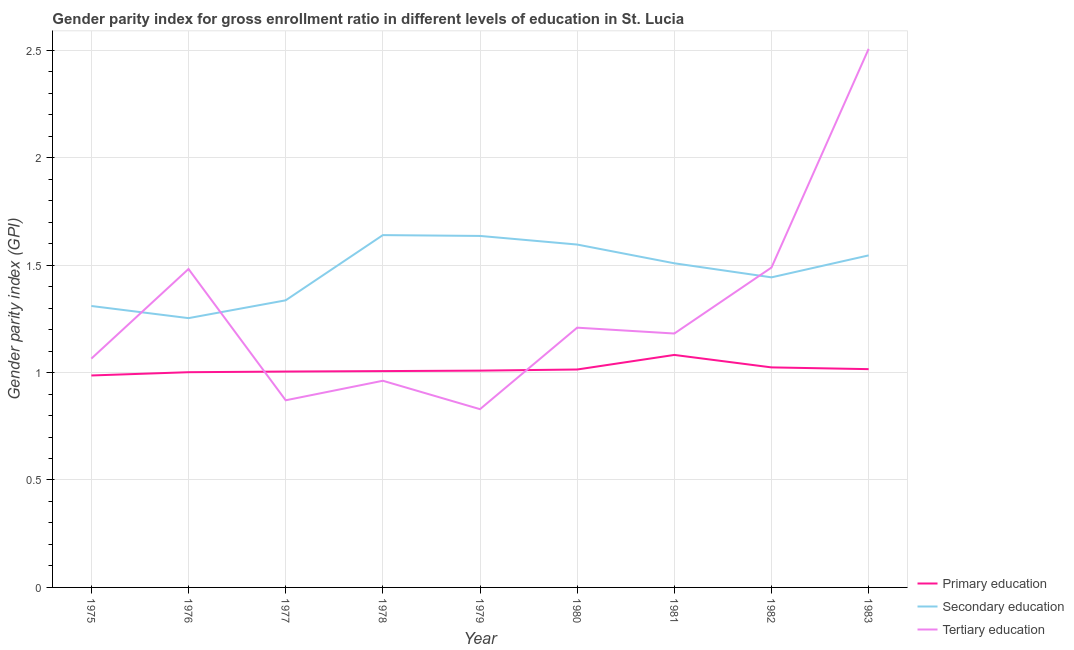How many different coloured lines are there?
Give a very brief answer. 3. Does the line corresponding to gender parity index in tertiary education intersect with the line corresponding to gender parity index in secondary education?
Ensure brevity in your answer.  Yes. What is the gender parity index in primary education in 1979?
Offer a very short reply. 1.01. Across all years, what is the maximum gender parity index in secondary education?
Your answer should be very brief. 1.64. Across all years, what is the minimum gender parity index in tertiary education?
Ensure brevity in your answer.  0.83. In which year was the gender parity index in secondary education maximum?
Provide a succinct answer. 1978. In which year was the gender parity index in tertiary education minimum?
Your response must be concise. 1979. What is the total gender parity index in primary education in the graph?
Your answer should be very brief. 9.14. What is the difference between the gender parity index in primary education in 1975 and that in 1983?
Your response must be concise. -0.03. What is the difference between the gender parity index in primary education in 1979 and the gender parity index in secondary education in 1978?
Your answer should be very brief. -0.63. What is the average gender parity index in tertiary education per year?
Provide a short and direct response. 1.29. In the year 1979, what is the difference between the gender parity index in tertiary education and gender parity index in primary education?
Your answer should be compact. -0.18. What is the ratio of the gender parity index in tertiary education in 1981 to that in 1983?
Your response must be concise. 0.47. Is the gender parity index in tertiary education in 1976 less than that in 1979?
Provide a short and direct response. No. What is the difference between the highest and the second highest gender parity index in tertiary education?
Provide a succinct answer. 1.02. What is the difference between the highest and the lowest gender parity index in primary education?
Your answer should be compact. 0.1. Is the sum of the gender parity index in tertiary education in 1976 and 1982 greater than the maximum gender parity index in secondary education across all years?
Offer a very short reply. Yes. Is it the case that in every year, the sum of the gender parity index in primary education and gender parity index in secondary education is greater than the gender parity index in tertiary education?
Your response must be concise. Yes. Does the gender parity index in primary education monotonically increase over the years?
Your answer should be compact. No. Is the gender parity index in tertiary education strictly less than the gender parity index in secondary education over the years?
Your response must be concise. No. How many years are there in the graph?
Give a very brief answer. 9. Are the values on the major ticks of Y-axis written in scientific E-notation?
Make the answer very short. No. How many legend labels are there?
Give a very brief answer. 3. What is the title of the graph?
Offer a terse response. Gender parity index for gross enrollment ratio in different levels of education in St. Lucia. Does "Maunufacturing" appear as one of the legend labels in the graph?
Make the answer very short. No. What is the label or title of the X-axis?
Provide a succinct answer. Year. What is the label or title of the Y-axis?
Provide a succinct answer. Gender parity index (GPI). What is the Gender parity index (GPI) of Primary education in 1975?
Offer a terse response. 0.99. What is the Gender parity index (GPI) in Secondary education in 1975?
Provide a short and direct response. 1.31. What is the Gender parity index (GPI) in Tertiary education in 1975?
Provide a short and direct response. 1.06. What is the Gender parity index (GPI) of Primary education in 1976?
Your answer should be compact. 1. What is the Gender parity index (GPI) in Secondary education in 1976?
Keep it short and to the point. 1.25. What is the Gender parity index (GPI) in Tertiary education in 1976?
Provide a short and direct response. 1.48. What is the Gender parity index (GPI) of Primary education in 1977?
Offer a terse response. 1. What is the Gender parity index (GPI) in Secondary education in 1977?
Your answer should be very brief. 1.34. What is the Gender parity index (GPI) in Tertiary education in 1977?
Keep it short and to the point. 0.87. What is the Gender parity index (GPI) in Primary education in 1978?
Keep it short and to the point. 1.01. What is the Gender parity index (GPI) of Secondary education in 1978?
Ensure brevity in your answer.  1.64. What is the Gender parity index (GPI) in Tertiary education in 1978?
Keep it short and to the point. 0.96. What is the Gender parity index (GPI) in Primary education in 1979?
Offer a terse response. 1.01. What is the Gender parity index (GPI) of Secondary education in 1979?
Make the answer very short. 1.64. What is the Gender parity index (GPI) in Tertiary education in 1979?
Offer a very short reply. 0.83. What is the Gender parity index (GPI) in Primary education in 1980?
Make the answer very short. 1.01. What is the Gender parity index (GPI) in Secondary education in 1980?
Keep it short and to the point. 1.6. What is the Gender parity index (GPI) in Tertiary education in 1980?
Offer a very short reply. 1.21. What is the Gender parity index (GPI) in Primary education in 1981?
Provide a succinct answer. 1.08. What is the Gender parity index (GPI) of Secondary education in 1981?
Give a very brief answer. 1.51. What is the Gender parity index (GPI) of Tertiary education in 1981?
Offer a terse response. 1.18. What is the Gender parity index (GPI) in Primary education in 1982?
Offer a very short reply. 1.02. What is the Gender parity index (GPI) of Secondary education in 1982?
Your response must be concise. 1.44. What is the Gender parity index (GPI) of Tertiary education in 1982?
Provide a short and direct response. 1.49. What is the Gender parity index (GPI) in Primary education in 1983?
Keep it short and to the point. 1.02. What is the Gender parity index (GPI) in Secondary education in 1983?
Provide a succinct answer. 1.55. What is the Gender parity index (GPI) of Tertiary education in 1983?
Make the answer very short. 2.51. Across all years, what is the maximum Gender parity index (GPI) in Primary education?
Give a very brief answer. 1.08. Across all years, what is the maximum Gender parity index (GPI) of Secondary education?
Give a very brief answer. 1.64. Across all years, what is the maximum Gender parity index (GPI) in Tertiary education?
Offer a very short reply. 2.51. Across all years, what is the minimum Gender parity index (GPI) of Primary education?
Your answer should be very brief. 0.99. Across all years, what is the minimum Gender parity index (GPI) of Secondary education?
Provide a short and direct response. 1.25. Across all years, what is the minimum Gender parity index (GPI) in Tertiary education?
Offer a very short reply. 0.83. What is the total Gender parity index (GPI) in Primary education in the graph?
Your answer should be compact. 9.14. What is the total Gender parity index (GPI) of Secondary education in the graph?
Make the answer very short. 13.27. What is the total Gender parity index (GPI) of Tertiary education in the graph?
Your response must be concise. 11.59. What is the difference between the Gender parity index (GPI) in Primary education in 1975 and that in 1976?
Your answer should be compact. -0.02. What is the difference between the Gender parity index (GPI) in Secondary education in 1975 and that in 1976?
Offer a terse response. 0.06. What is the difference between the Gender parity index (GPI) of Tertiary education in 1975 and that in 1976?
Provide a succinct answer. -0.42. What is the difference between the Gender parity index (GPI) of Primary education in 1975 and that in 1977?
Provide a succinct answer. -0.02. What is the difference between the Gender parity index (GPI) in Secondary education in 1975 and that in 1977?
Offer a terse response. -0.03. What is the difference between the Gender parity index (GPI) of Tertiary education in 1975 and that in 1977?
Your answer should be compact. 0.19. What is the difference between the Gender parity index (GPI) in Primary education in 1975 and that in 1978?
Offer a terse response. -0.02. What is the difference between the Gender parity index (GPI) in Secondary education in 1975 and that in 1978?
Your answer should be very brief. -0.33. What is the difference between the Gender parity index (GPI) in Tertiary education in 1975 and that in 1978?
Ensure brevity in your answer.  0.1. What is the difference between the Gender parity index (GPI) of Primary education in 1975 and that in 1979?
Ensure brevity in your answer.  -0.02. What is the difference between the Gender parity index (GPI) in Secondary education in 1975 and that in 1979?
Your answer should be very brief. -0.33. What is the difference between the Gender parity index (GPI) in Tertiary education in 1975 and that in 1979?
Provide a short and direct response. 0.24. What is the difference between the Gender parity index (GPI) of Primary education in 1975 and that in 1980?
Provide a short and direct response. -0.03. What is the difference between the Gender parity index (GPI) in Secondary education in 1975 and that in 1980?
Your answer should be compact. -0.29. What is the difference between the Gender parity index (GPI) in Tertiary education in 1975 and that in 1980?
Give a very brief answer. -0.14. What is the difference between the Gender parity index (GPI) of Primary education in 1975 and that in 1981?
Offer a very short reply. -0.1. What is the difference between the Gender parity index (GPI) in Secondary education in 1975 and that in 1981?
Give a very brief answer. -0.2. What is the difference between the Gender parity index (GPI) in Tertiary education in 1975 and that in 1981?
Offer a terse response. -0.12. What is the difference between the Gender parity index (GPI) of Primary education in 1975 and that in 1982?
Your response must be concise. -0.04. What is the difference between the Gender parity index (GPI) in Secondary education in 1975 and that in 1982?
Provide a succinct answer. -0.13. What is the difference between the Gender parity index (GPI) in Tertiary education in 1975 and that in 1982?
Your answer should be very brief. -0.42. What is the difference between the Gender parity index (GPI) in Primary education in 1975 and that in 1983?
Provide a succinct answer. -0.03. What is the difference between the Gender parity index (GPI) of Secondary education in 1975 and that in 1983?
Make the answer very short. -0.24. What is the difference between the Gender parity index (GPI) in Tertiary education in 1975 and that in 1983?
Ensure brevity in your answer.  -1.44. What is the difference between the Gender parity index (GPI) of Primary education in 1976 and that in 1977?
Keep it short and to the point. -0. What is the difference between the Gender parity index (GPI) of Secondary education in 1976 and that in 1977?
Your answer should be compact. -0.08. What is the difference between the Gender parity index (GPI) of Tertiary education in 1976 and that in 1977?
Make the answer very short. 0.61. What is the difference between the Gender parity index (GPI) of Primary education in 1976 and that in 1978?
Keep it short and to the point. -0.01. What is the difference between the Gender parity index (GPI) in Secondary education in 1976 and that in 1978?
Provide a short and direct response. -0.39. What is the difference between the Gender parity index (GPI) of Tertiary education in 1976 and that in 1978?
Offer a very short reply. 0.52. What is the difference between the Gender parity index (GPI) of Primary education in 1976 and that in 1979?
Make the answer very short. -0.01. What is the difference between the Gender parity index (GPI) in Secondary education in 1976 and that in 1979?
Provide a succinct answer. -0.38. What is the difference between the Gender parity index (GPI) in Tertiary education in 1976 and that in 1979?
Make the answer very short. 0.65. What is the difference between the Gender parity index (GPI) of Primary education in 1976 and that in 1980?
Keep it short and to the point. -0.01. What is the difference between the Gender parity index (GPI) in Secondary education in 1976 and that in 1980?
Make the answer very short. -0.34. What is the difference between the Gender parity index (GPI) of Tertiary education in 1976 and that in 1980?
Provide a succinct answer. 0.27. What is the difference between the Gender parity index (GPI) of Primary education in 1976 and that in 1981?
Ensure brevity in your answer.  -0.08. What is the difference between the Gender parity index (GPI) of Secondary education in 1976 and that in 1981?
Keep it short and to the point. -0.26. What is the difference between the Gender parity index (GPI) in Tertiary education in 1976 and that in 1981?
Provide a short and direct response. 0.3. What is the difference between the Gender parity index (GPI) of Primary education in 1976 and that in 1982?
Ensure brevity in your answer.  -0.02. What is the difference between the Gender parity index (GPI) in Secondary education in 1976 and that in 1982?
Make the answer very short. -0.19. What is the difference between the Gender parity index (GPI) of Tertiary education in 1976 and that in 1982?
Your answer should be compact. -0.01. What is the difference between the Gender parity index (GPI) in Primary education in 1976 and that in 1983?
Offer a terse response. -0.01. What is the difference between the Gender parity index (GPI) in Secondary education in 1976 and that in 1983?
Your answer should be compact. -0.29. What is the difference between the Gender parity index (GPI) in Tertiary education in 1976 and that in 1983?
Ensure brevity in your answer.  -1.02. What is the difference between the Gender parity index (GPI) in Primary education in 1977 and that in 1978?
Ensure brevity in your answer.  -0. What is the difference between the Gender parity index (GPI) of Secondary education in 1977 and that in 1978?
Your answer should be very brief. -0.3. What is the difference between the Gender parity index (GPI) of Tertiary education in 1977 and that in 1978?
Your answer should be compact. -0.09. What is the difference between the Gender parity index (GPI) in Primary education in 1977 and that in 1979?
Your response must be concise. -0. What is the difference between the Gender parity index (GPI) in Secondary education in 1977 and that in 1979?
Ensure brevity in your answer.  -0.3. What is the difference between the Gender parity index (GPI) in Tertiary education in 1977 and that in 1979?
Make the answer very short. 0.04. What is the difference between the Gender parity index (GPI) in Primary education in 1977 and that in 1980?
Provide a succinct answer. -0.01. What is the difference between the Gender parity index (GPI) in Secondary education in 1977 and that in 1980?
Give a very brief answer. -0.26. What is the difference between the Gender parity index (GPI) in Tertiary education in 1977 and that in 1980?
Your response must be concise. -0.34. What is the difference between the Gender parity index (GPI) in Primary education in 1977 and that in 1981?
Provide a succinct answer. -0.08. What is the difference between the Gender parity index (GPI) of Secondary education in 1977 and that in 1981?
Your response must be concise. -0.17. What is the difference between the Gender parity index (GPI) in Tertiary education in 1977 and that in 1981?
Your answer should be very brief. -0.31. What is the difference between the Gender parity index (GPI) of Primary education in 1977 and that in 1982?
Your answer should be compact. -0.02. What is the difference between the Gender parity index (GPI) of Secondary education in 1977 and that in 1982?
Give a very brief answer. -0.11. What is the difference between the Gender parity index (GPI) in Tertiary education in 1977 and that in 1982?
Keep it short and to the point. -0.62. What is the difference between the Gender parity index (GPI) in Primary education in 1977 and that in 1983?
Your answer should be compact. -0.01. What is the difference between the Gender parity index (GPI) of Secondary education in 1977 and that in 1983?
Offer a very short reply. -0.21. What is the difference between the Gender parity index (GPI) of Tertiary education in 1977 and that in 1983?
Your response must be concise. -1.64. What is the difference between the Gender parity index (GPI) in Primary education in 1978 and that in 1979?
Your response must be concise. -0. What is the difference between the Gender parity index (GPI) in Secondary education in 1978 and that in 1979?
Offer a very short reply. 0. What is the difference between the Gender parity index (GPI) in Tertiary education in 1978 and that in 1979?
Keep it short and to the point. 0.13. What is the difference between the Gender parity index (GPI) in Primary education in 1978 and that in 1980?
Your answer should be very brief. -0.01. What is the difference between the Gender parity index (GPI) in Secondary education in 1978 and that in 1980?
Provide a succinct answer. 0.04. What is the difference between the Gender parity index (GPI) in Tertiary education in 1978 and that in 1980?
Provide a succinct answer. -0.25. What is the difference between the Gender parity index (GPI) of Primary education in 1978 and that in 1981?
Your answer should be very brief. -0.08. What is the difference between the Gender parity index (GPI) in Secondary education in 1978 and that in 1981?
Give a very brief answer. 0.13. What is the difference between the Gender parity index (GPI) of Tertiary education in 1978 and that in 1981?
Offer a terse response. -0.22. What is the difference between the Gender parity index (GPI) in Primary education in 1978 and that in 1982?
Provide a short and direct response. -0.02. What is the difference between the Gender parity index (GPI) of Secondary education in 1978 and that in 1982?
Provide a succinct answer. 0.2. What is the difference between the Gender parity index (GPI) in Tertiary education in 1978 and that in 1982?
Give a very brief answer. -0.53. What is the difference between the Gender parity index (GPI) in Primary education in 1978 and that in 1983?
Make the answer very short. -0.01. What is the difference between the Gender parity index (GPI) of Secondary education in 1978 and that in 1983?
Keep it short and to the point. 0.09. What is the difference between the Gender parity index (GPI) in Tertiary education in 1978 and that in 1983?
Provide a short and direct response. -1.54. What is the difference between the Gender parity index (GPI) in Primary education in 1979 and that in 1980?
Offer a terse response. -0.01. What is the difference between the Gender parity index (GPI) of Secondary education in 1979 and that in 1980?
Offer a very short reply. 0.04. What is the difference between the Gender parity index (GPI) in Tertiary education in 1979 and that in 1980?
Offer a very short reply. -0.38. What is the difference between the Gender parity index (GPI) in Primary education in 1979 and that in 1981?
Ensure brevity in your answer.  -0.07. What is the difference between the Gender parity index (GPI) of Secondary education in 1979 and that in 1981?
Provide a short and direct response. 0.13. What is the difference between the Gender parity index (GPI) in Tertiary education in 1979 and that in 1981?
Your answer should be very brief. -0.35. What is the difference between the Gender parity index (GPI) of Primary education in 1979 and that in 1982?
Offer a very short reply. -0.01. What is the difference between the Gender parity index (GPI) in Secondary education in 1979 and that in 1982?
Give a very brief answer. 0.19. What is the difference between the Gender parity index (GPI) of Tertiary education in 1979 and that in 1982?
Keep it short and to the point. -0.66. What is the difference between the Gender parity index (GPI) in Primary education in 1979 and that in 1983?
Keep it short and to the point. -0.01. What is the difference between the Gender parity index (GPI) of Secondary education in 1979 and that in 1983?
Provide a short and direct response. 0.09. What is the difference between the Gender parity index (GPI) in Tertiary education in 1979 and that in 1983?
Provide a succinct answer. -1.68. What is the difference between the Gender parity index (GPI) in Primary education in 1980 and that in 1981?
Your answer should be compact. -0.07. What is the difference between the Gender parity index (GPI) of Secondary education in 1980 and that in 1981?
Your response must be concise. 0.09. What is the difference between the Gender parity index (GPI) in Tertiary education in 1980 and that in 1981?
Give a very brief answer. 0.03. What is the difference between the Gender parity index (GPI) in Primary education in 1980 and that in 1982?
Offer a very short reply. -0.01. What is the difference between the Gender parity index (GPI) of Secondary education in 1980 and that in 1982?
Keep it short and to the point. 0.15. What is the difference between the Gender parity index (GPI) in Tertiary education in 1980 and that in 1982?
Make the answer very short. -0.28. What is the difference between the Gender parity index (GPI) in Primary education in 1980 and that in 1983?
Keep it short and to the point. -0. What is the difference between the Gender parity index (GPI) of Secondary education in 1980 and that in 1983?
Give a very brief answer. 0.05. What is the difference between the Gender parity index (GPI) in Tertiary education in 1980 and that in 1983?
Make the answer very short. -1.3. What is the difference between the Gender parity index (GPI) of Primary education in 1981 and that in 1982?
Your answer should be compact. 0.06. What is the difference between the Gender parity index (GPI) of Secondary education in 1981 and that in 1982?
Offer a terse response. 0.07. What is the difference between the Gender parity index (GPI) in Tertiary education in 1981 and that in 1982?
Provide a short and direct response. -0.31. What is the difference between the Gender parity index (GPI) in Primary education in 1981 and that in 1983?
Make the answer very short. 0.07. What is the difference between the Gender parity index (GPI) in Secondary education in 1981 and that in 1983?
Offer a very short reply. -0.04. What is the difference between the Gender parity index (GPI) of Tertiary education in 1981 and that in 1983?
Offer a terse response. -1.32. What is the difference between the Gender parity index (GPI) in Primary education in 1982 and that in 1983?
Offer a terse response. 0.01. What is the difference between the Gender parity index (GPI) of Secondary education in 1982 and that in 1983?
Make the answer very short. -0.1. What is the difference between the Gender parity index (GPI) in Tertiary education in 1982 and that in 1983?
Offer a terse response. -1.02. What is the difference between the Gender parity index (GPI) of Primary education in 1975 and the Gender parity index (GPI) of Secondary education in 1976?
Offer a terse response. -0.27. What is the difference between the Gender parity index (GPI) in Primary education in 1975 and the Gender parity index (GPI) in Tertiary education in 1976?
Offer a terse response. -0.5. What is the difference between the Gender parity index (GPI) of Secondary education in 1975 and the Gender parity index (GPI) of Tertiary education in 1976?
Provide a short and direct response. -0.17. What is the difference between the Gender parity index (GPI) in Primary education in 1975 and the Gender parity index (GPI) in Secondary education in 1977?
Provide a succinct answer. -0.35. What is the difference between the Gender parity index (GPI) in Primary education in 1975 and the Gender parity index (GPI) in Tertiary education in 1977?
Keep it short and to the point. 0.12. What is the difference between the Gender parity index (GPI) of Secondary education in 1975 and the Gender parity index (GPI) of Tertiary education in 1977?
Offer a very short reply. 0.44. What is the difference between the Gender parity index (GPI) of Primary education in 1975 and the Gender parity index (GPI) of Secondary education in 1978?
Your answer should be very brief. -0.65. What is the difference between the Gender parity index (GPI) in Primary education in 1975 and the Gender parity index (GPI) in Tertiary education in 1978?
Ensure brevity in your answer.  0.02. What is the difference between the Gender parity index (GPI) of Secondary education in 1975 and the Gender parity index (GPI) of Tertiary education in 1978?
Your response must be concise. 0.35. What is the difference between the Gender parity index (GPI) in Primary education in 1975 and the Gender parity index (GPI) in Secondary education in 1979?
Your answer should be very brief. -0.65. What is the difference between the Gender parity index (GPI) in Primary education in 1975 and the Gender parity index (GPI) in Tertiary education in 1979?
Provide a short and direct response. 0.16. What is the difference between the Gender parity index (GPI) of Secondary education in 1975 and the Gender parity index (GPI) of Tertiary education in 1979?
Provide a succinct answer. 0.48. What is the difference between the Gender parity index (GPI) of Primary education in 1975 and the Gender parity index (GPI) of Secondary education in 1980?
Offer a terse response. -0.61. What is the difference between the Gender parity index (GPI) in Primary education in 1975 and the Gender parity index (GPI) in Tertiary education in 1980?
Give a very brief answer. -0.22. What is the difference between the Gender parity index (GPI) in Secondary education in 1975 and the Gender parity index (GPI) in Tertiary education in 1980?
Provide a short and direct response. 0.1. What is the difference between the Gender parity index (GPI) of Primary education in 1975 and the Gender parity index (GPI) of Secondary education in 1981?
Your answer should be compact. -0.52. What is the difference between the Gender parity index (GPI) of Primary education in 1975 and the Gender parity index (GPI) of Tertiary education in 1981?
Ensure brevity in your answer.  -0.2. What is the difference between the Gender parity index (GPI) of Secondary education in 1975 and the Gender parity index (GPI) of Tertiary education in 1981?
Provide a succinct answer. 0.13. What is the difference between the Gender parity index (GPI) in Primary education in 1975 and the Gender parity index (GPI) in Secondary education in 1982?
Your response must be concise. -0.46. What is the difference between the Gender parity index (GPI) of Primary education in 1975 and the Gender parity index (GPI) of Tertiary education in 1982?
Offer a terse response. -0.5. What is the difference between the Gender parity index (GPI) in Secondary education in 1975 and the Gender parity index (GPI) in Tertiary education in 1982?
Make the answer very short. -0.18. What is the difference between the Gender parity index (GPI) of Primary education in 1975 and the Gender parity index (GPI) of Secondary education in 1983?
Keep it short and to the point. -0.56. What is the difference between the Gender parity index (GPI) in Primary education in 1975 and the Gender parity index (GPI) in Tertiary education in 1983?
Provide a succinct answer. -1.52. What is the difference between the Gender parity index (GPI) of Secondary education in 1975 and the Gender parity index (GPI) of Tertiary education in 1983?
Make the answer very short. -1.2. What is the difference between the Gender parity index (GPI) in Primary education in 1976 and the Gender parity index (GPI) in Secondary education in 1977?
Provide a short and direct response. -0.33. What is the difference between the Gender parity index (GPI) of Primary education in 1976 and the Gender parity index (GPI) of Tertiary education in 1977?
Offer a very short reply. 0.13. What is the difference between the Gender parity index (GPI) of Secondary education in 1976 and the Gender parity index (GPI) of Tertiary education in 1977?
Provide a short and direct response. 0.38. What is the difference between the Gender parity index (GPI) in Primary education in 1976 and the Gender parity index (GPI) in Secondary education in 1978?
Offer a very short reply. -0.64. What is the difference between the Gender parity index (GPI) of Primary education in 1976 and the Gender parity index (GPI) of Tertiary education in 1978?
Your answer should be compact. 0.04. What is the difference between the Gender parity index (GPI) in Secondary education in 1976 and the Gender parity index (GPI) in Tertiary education in 1978?
Offer a very short reply. 0.29. What is the difference between the Gender parity index (GPI) in Primary education in 1976 and the Gender parity index (GPI) in Secondary education in 1979?
Make the answer very short. -0.63. What is the difference between the Gender parity index (GPI) of Primary education in 1976 and the Gender parity index (GPI) of Tertiary education in 1979?
Offer a terse response. 0.17. What is the difference between the Gender parity index (GPI) in Secondary education in 1976 and the Gender parity index (GPI) in Tertiary education in 1979?
Make the answer very short. 0.42. What is the difference between the Gender parity index (GPI) of Primary education in 1976 and the Gender parity index (GPI) of Secondary education in 1980?
Your answer should be very brief. -0.59. What is the difference between the Gender parity index (GPI) of Primary education in 1976 and the Gender parity index (GPI) of Tertiary education in 1980?
Offer a very short reply. -0.21. What is the difference between the Gender parity index (GPI) in Secondary education in 1976 and the Gender parity index (GPI) in Tertiary education in 1980?
Make the answer very short. 0.04. What is the difference between the Gender parity index (GPI) of Primary education in 1976 and the Gender parity index (GPI) of Secondary education in 1981?
Your answer should be very brief. -0.51. What is the difference between the Gender parity index (GPI) of Primary education in 1976 and the Gender parity index (GPI) of Tertiary education in 1981?
Keep it short and to the point. -0.18. What is the difference between the Gender parity index (GPI) of Secondary education in 1976 and the Gender parity index (GPI) of Tertiary education in 1981?
Ensure brevity in your answer.  0.07. What is the difference between the Gender parity index (GPI) of Primary education in 1976 and the Gender parity index (GPI) of Secondary education in 1982?
Give a very brief answer. -0.44. What is the difference between the Gender parity index (GPI) in Primary education in 1976 and the Gender parity index (GPI) in Tertiary education in 1982?
Your response must be concise. -0.49. What is the difference between the Gender parity index (GPI) of Secondary education in 1976 and the Gender parity index (GPI) of Tertiary education in 1982?
Offer a very short reply. -0.24. What is the difference between the Gender parity index (GPI) of Primary education in 1976 and the Gender parity index (GPI) of Secondary education in 1983?
Ensure brevity in your answer.  -0.54. What is the difference between the Gender parity index (GPI) of Primary education in 1976 and the Gender parity index (GPI) of Tertiary education in 1983?
Your response must be concise. -1.5. What is the difference between the Gender parity index (GPI) in Secondary education in 1976 and the Gender parity index (GPI) in Tertiary education in 1983?
Make the answer very short. -1.25. What is the difference between the Gender parity index (GPI) of Primary education in 1977 and the Gender parity index (GPI) of Secondary education in 1978?
Give a very brief answer. -0.64. What is the difference between the Gender parity index (GPI) of Primary education in 1977 and the Gender parity index (GPI) of Tertiary education in 1978?
Your answer should be very brief. 0.04. What is the difference between the Gender parity index (GPI) of Secondary education in 1977 and the Gender parity index (GPI) of Tertiary education in 1978?
Keep it short and to the point. 0.37. What is the difference between the Gender parity index (GPI) of Primary education in 1977 and the Gender parity index (GPI) of Secondary education in 1979?
Your answer should be very brief. -0.63. What is the difference between the Gender parity index (GPI) in Primary education in 1977 and the Gender parity index (GPI) in Tertiary education in 1979?
Your response must be concise. 0.17. What is the difference between the Gender parity index (GPI) of Secondary education in 1977 and the Gender parity index (GPI) of Tertiary education in 1979?
Provide a short and direct response. 0.51. What is the difference between the Gender parity index (GPI) in Primary education in 1977 and the Gender parity index (GPI) in Secondary education in 1980?
Keep it short and to the point. -0.59. What is the difference between the Gender parity index (GPI) in Primary education in 1977 and the Gender parity index (GPI) in Tertiary education in 1980?
Offer a terse response. -0.2. What is the difference between the Gender parity index (GPI) of Secondary education in 1977 and the Gender parity index (GPI) of Tertiary education in 1980?
Your response must be concise. 0.13. What is the difference between the Gender parity index (GPI) of Primary education in 1977 and the Gender parity index (GPI) of Secondary education in 1981?
Offer a terse response. -0.5. What is the difference between the Gender parity index (GPI) in Primary education in 1977 and the Gender parity index (GPI) in Tertiary education in 1981?
Keep it short and to the point. -0.18. What is the difference between the Gender parity index (GPI) of Secondary education in 1977 and the Gender parity index (GPI) of Tertiary education in 1981?
Ensure brevity in your answer.  0.15. What is the difference between the Gender parity index (GPI) of Primary education in 1977 and the Gender parity index (GPI) of Secondary education in 1982?
Offer a very short reply. -0.44. What is the difference between the Gender parity index (GPI) in Primary education in 1977 and the Gender parity index (GPI) in Tertiary education in 1982?
Keep it short and to the point. -0.48. What is the difference between the Gender parity index (GPI) in Secondary education in 1977 and the Gender parity index (GPI) in Tertiary education in 1982?
Keep it short and to the point. -0.15. What is the difference between the Gender parity index (GPI) of Primary education in 1977 and the Gender parity index (GPI) of Secondary education in 1983?
Offer a very short reply. -0.54. What is the difference between the Gender parity index (GPI) of Primary education in 1977 and the Gender parity index (GPI) of Tertiary education in 1983?
Your response must be concise. -1.5. What is the difference between the Gender parity index (GPI) in Secondary education in 1977 and the Gender parity index (GPI) in Tertiary education in 1983?
Offer a terse response. -1.17. What is the difference between the Gender parity index (GPI) of Primary education in 1978 and the Gender parity index (GPI) of Secondary education in 1979?
Provide a succinct answer. -0.63. What is the difference between the Gender parity index (GPI) of Primary education in 1978 and the Gender parity index (GPI) of Tertiary education in 1979?
Provide a short and direct response. 0.18. What is the difference between the Gender parity index (GPI) in Secondary education in 1978 and the Gender parity index (GPI) in Tertiary education in 1979?
Your answer should be compact. 0.81. What is the difference between the Gender parity index (GPI) in Primary education in 1978 and the Gender parity index (GPI) in Secondary education in 1980?
Provide a short and direct response. -0.59. What is the difference between the Gender parity index (GPI) of Primary education in 1978 and the Gender parity index (GPI) of Tertiary education in 1980?
Keep it short and to the point. -0.2. What is the difference between the Gender parity index (GPI) of Secondary education in 1978 and the Gender parity index (GPI) of Tertiary education in 1980?
Your answer should be compact. 0.43. What is the difference between the Gender parity index (GPI) in Primary education in 1978 and the Gender parity index (GPI) in Secondary education in 1981?
Ensure brevity in your answer.  -0.5. What is the difference between the Gender parity index (GPI) in Primary education in 1978 and the Gender parity index (GPI) in Tertiary education in 1981?
Provide a succinct answer. -0.17. What is the difference between the Gender parity index (GPI) of Secondary education in 1978 and the Gender parity index (GPI) of Tertiary education in 1981?
Ensure brevity in your answer.  0.46. What is the difference between the Gender parity index (GPI) of Primary education in 1978 and the Gender parity index (GPI) of Secondary education in 1982?
Your answer should be compact. -0.44. What is the difference between the Gender parity index (GPI) of Primary education in 1978 and the Gender parity index (GPI) of Tertiary education in 1982?
Your response must be concise. -0.48. What is the difference between the Gender parity index (GPI) in Secondary education in 1978 and the Gender parity index (GPI) in Tertiary education in 1982?
Offer a terse response. 0.15. What is the difference between the Gender parity index (GPI) of Primary education in 1978 and the Gender parity index (GPI) of Secondary education in 1983?
Offer a very short reply. -0.54. What is the difference between the Gender parity index (GPI) in Primary education in 1978 and the Gender parity index (GPI) in Tertiary education in 1983?
Offer a terse response. -1.5. What is the difference between the Gender parity index (GPI) in Secondary education in 1978 and the Gender parity index (GPI) in Tertiary education in 1983?
Offer a terse response. -0.87. What is the difference between the Gender parity index (GPI) in Primary education in 1979 and the Gender parity index (GPI) in Secondary education in 1980?
Ensure brevity in your answer.  -0.59. What is the difference between the Gender parity index (GPI) in Primary education in 1979 and the Gender parity index (GPI) in Tertiary education in 1980?
Give a very brief answer. -0.2. What is the difference between the Gender parity index (GPI) in Secondary education in 1979 and the Gender parity index (GPI) in Tertiary education in 1980?
Offer a very short reply. 0.43. What is the difference between the Gender parity index (GPI) in Primary education in 1979 and the Gender parity index (GPI) in Secondary education in 1981?
Ensure brevity in your answer.  -0.5. What is the difference between the Gender parity index (GPI) in Primary education in 1979 and the Gender parity index (GPI) in Tertiary education in 1981?
Your answer should be very brief. -0.17. What is the difference between the Gender parity index (GPI) in Secondary education in 1979 and the Gender parity index (GPI) in Tertiary education in 1981?
Give a very brief answer. 0.45. What is the difference between the Gender parity index (GPI) of Primary education in 1979 and the Gender parity index (GPI) of Secondary education in 1982?
Give a very brief answer. -0.43. What is the difference between the Gender parity index (GPI) of Primary education in 1979 and the Gender parity index (GPI) of Tertiary education in 1982?
Keep it short and to the point. -0.48. What is the difference between the Gender parity index (GPI) of Secondary education in 1979 and the Gender parity index (GPI) of Tertiary education in 1982?
Provide a succinct answer. 0.15. What is the difference between the Gender parity index (GPI) in Primary education in 1979 and the Gender parity index (GPI) in Secondary education in 1983?
Offer a terse response. -0.54. What is the difference between the Gender parity index (GPI) of Primary education in 1979 and the Gender parity index (GPI) of Tertiary education in 1983?
Give a very brief answer. -1.5. What is the difference between the Gender parity index (GPI) in Secondary education in 1979 and the Gender parity index (GPI) in Tertiary education in 1983?
Offer a terse response. -0.87. What is the difference between the Gender parity index (GPI) of Primary education in 1980 and the Gender parity index (GPI) of Secondary education in 1981?
Make the answer very short. -0.49. What is the difference between the Gender parity index (GPI) of Primary education in 1980 and the Gender parity index (GPI) of Tertiary education in 1981?
Your answer should be very brief. -0.17. What is the difference between the Gender parity index (GPI) in Secondary education in 1980 and the Gender parity index (GPI) in Tertiary education in 1981?
Your answer should be very brief. 0.41. What is the difference between the Gender parity index (GPI) of Primary education in 1980 and the Gender parity index (GPI) of Secondary education in 1982?
Your answer should be compact. -0.43. What is the difference between the Gender parity index (GPI) in Primary education in 1980 and the Gender parity index (GPI) in Tertiary education in 1982?
Provide a short and direct response. -0.47. What is the difference between the Gender parity index (GPI) of Secondary education in 1980 and the Gender parity index (GPI) of Tertiary education in 1982?
Keep it short and to the point. 0.11. What is the difference between the Gender parity index (GPI) of Primary education in 1980 and the Gender parity index (GPI) of Secondary education in 1983?
Your answer should be very brief. -0.53. What is the difference between the Gender parity index (GPI) of Primary education in 1980 and the Gender parity index (GPI) of Tertiary education in 1983?
Ensure brevity in your answer.  -1.49. What is the difference between the Gender parity index (GPI) of Secondary education in 1980 and the Gender parity index (GPI) of Tertiary education in 1983?
Your answer should be very brief. -0.91. What is the difference between the Gender parity index (GPI) of Primary education in 1981 and the Gender parity index (GPI) of Secondary education in 1982?
Keep it short and to the point. -0.36. What is the difference between the Gender parity index (GPI) in Primary education in 1981 and the Gender parity index (GPI) in Tertiary education in 1982?
Provide a succinct answer. -0.41. What is the difference between the Gender parity index (GPI) in Secondary education in 1981 and the Gender parity index (GPI) in Tertiary education in 1982?
Offer a very short reply. 0.02. What is the difference between the Gender parity index (GPI) of Primary education in 1981 and the Gender parity index (GPI) of Secondary education in 1983?
Your answer should be very brief. -0.46. What is the difference between the Gender parity index (GPI) in Primary education in 1981 and the Gender parity index (GPI) in Tertiary education in 1983?
Offer a terse response. -1.42. What is the difference between the Gender parity index (GPI) in Secondary education in 1981 and the Gender parity index (GPI) in Tertiary education in 1983?
Make the answer very short. -1. What is the difference between the Gender parity index (GPI) of Primary education in 1982 and the Gender parity index (GPI) of Secondary education in 1983?
Offer a very short reply. -0.52. What is the difference between the Gender parity index (GPI) of Primary education in 1982 and the Gender parity index (GPI) of Tertiary education in 1983?
Provide a short and direct response. -1.48. What is the difference between the Gender parity index (GPI) in Secondary education in 1982 and the Gender parity index (GPI) in Tertiary education in 1983?
Your response must be concise. -1.06. What is the average Gender parity index (GPI) in Secondary education per year?
Provide a short and direct response. 1.47. What is the average Gender parity index (GPI) of Tertiary education per year?
Offer a very short reply. 1.29. In the year 1975, what is the difference between the Gender parity index (GPI) in Primary education and Gender parity index (GPI) in Secondary education?
Ensure brevity in your answer.  -0.32. In the year 1975, what is the difference between the Gender parity index (GPI) in Primary education and Gender parity index (GPI) in Tertiary education?
Offer a very short reply. -0.08. In the year 1975, what is the difference between the Gender parity index (GPI) of Secondary education and Gender parity index (GPI) of Tertiary education?
Give a very brief answer. 0.24. In the year 1976, what is the difference between the Gender parity index (GPI) of Primary education and Gender parity index (GPI) of Secondary education?
Provide a succinct answer. -0.25. In the year 1976, what is the difference between the Gender parity index (GPI) of Primary education and Gender parity index (GPI) of Tertiary education?
Your response must be concise. -0.48. In the year 1976, what is the difference between the Gender parity index (GPI) of Secondary education and Gender parity index (GPI) of Tertiary education?
Keep it short and to the point. -0.23. In the year 1977, what is the difference between the Gender parity index (GPI) in Primary education and Gender parity index (GPI) in Secondary education?
Your answer should be very brief. -0.33. In the year 1977, what is the difference between the Gender parity index (GPI) in Primary education and Gender parity index (GPI) in Tertiary education?
Your answer should be very brief. 0.13. In the year 1977, what is the difference between the Gender parity index (GPI) in Secondary education and Gender parity index (GPI) in Tertiary education?
Offer a very short reply. 0.47. In the year 1978, what is the difference between the Gender parity index (GPI) of Primary education and Gender parity index (GPI) of Secondary education?
Your response must be concise. -0.63. In the year 1978, what is the difference between the Gender parity index (GPI) of Primary education and Gender parity index (GPI) of Tertiary education?
Offer a very short reply. 0.04. In the year 1978, what is the difference between the Gender parity index (GPI) in Secondary education and Gender parity index (GPI) in Tertiary education?
Your response must be concise. 0.68. In the year 1979, what is the difference between the Gender parity index (GPI) in Primary education and Gender parity index (GPI) in Secondary education?
Your response must be concise. -0.63. In the year 1979, what is the difference between the Gender parity index (GPI) of Primary education and Gender parity index (GPI) of Tertiary education?
Keep it short and to the point. 0.18. In the year 1979, what is the difference between the Gender parity index (GPI) of Secondary education and Gender parity index (GPI) of Tertiary education?
Your answer should be compact. 0.81. In the year 1980, what is the difference between the Gender parity index (GPI) of Primary education and Gender parity index (GPI) of Secondary education?
Provide a succinct answer. -0.58. In the year 1980, what is the difference between the Gender parity index (GPI) of Primary education and Gender parity index (GPI) of Tertiary education?
Provide a succinct answer. -0.19. In the year 1980, what is the difference between the Gender parity index (GPI) of Secondary education and Gender parity index (GPI) of Tertiary education?
Provide a succinct answer. 0.39. In the year 1981, what is the difference between the Gender parity index (GPI) of Primary education and Gender parity index (GPI) of Secondary education?
Offer a terse response. -0.43. In the year 1981, what is the difference between the Gender parity index (GPI) in Primary education and Gender parity index (GPI) in Tertiary education?
Your response must be concise. -0.1. In the year 1981, what is the difference between the Gender parity index (GPI) in Secondary education and Gender parity index (GPI) in Tertiary education?
Offer a very short reply. 0.33. In the year 1982, what is the difference between the Gender parity index (GPI) in Primary education and Gender parity index (GPI) in Secondary education?
Ensure brevity in your answer.  -0.42. In the year 1982, what is the difference between the Gender parity index (GPI) in Primary education and Gender parity index (GPI) in Tertiary education?
Offer a terse response. -0.46. In the year 1982, what is the difference between the Gender parity index (GPI) of Secondary education and Gender parity index (GPI) of Tertiary education?
Ensure brevity in your answer.  -0.05. In the year 1983, what is the difference between the Gender parity index (GPI) in Primary education and Gender parity index (GPI) in Secondary education?
Your response must be concise. -0.53. In the year 1983, what is the difference between the Gender parity index (GPI) in Primary education and Gender parity index (GPI) in Tertiary education?
Your response must be concise. -1.49. In the year 1983, what is the difference between the Gender parity index (GPI) of Secondary education and Gender parity index (GPI) of Tertiary education?
Provide a short and direct response. -0.96. What is the ratio of the Gender parity index (GPI) of Primary education in 1975 to that in 1976?
Offer a terse response. 0.98. What is the ratio of the Gender parity index (GPI) in Secondary education in 1975 to that in 1976?
Provide a succinct answer. 1.05. What is the ratio of the Gender parity index (GPI) of Tertiary education in 1975 to that in 1976?
Give a very brief answer. 0.72. What is the ratio of the Gender parity index (GPI) in Primary education in 1975 to that in 1977?
Provide a succinct answer. 0.98. What is the ratio of the Gender parity index (GPI) of Secondary education in 1975 to that in 1977?
Provide a succinct answer. 0.98. What is the ratio of the Gender parity index (GPI) of Tertiary education in 1975 to that in 1977?
Your answer should be very brief. 1.22. What is the ratio of the Gender parity index (GPI) of Primary education in 1975 to that in 1978?
Provide a succinct answer. 0.98. What is the ratio of the Gender parity index (GPI) of Secondary education in 1975 to that in 1978?
Provide a succinct answer. 0.8. What is the ratio of the Gender parity index (GPI) in Tertiary education in 1975 to that in 1978?
Offer a very short reply. 1.11. What is the ratio of the Gender parity index (GPI) of Primary education in 1975 to that in 1979?
Give a very brief answer. 0.98. What is the ratio of the Gender parity index (GPI) of Secondary education in 1975 to that in 1979?
Your response must be concise. 0.8. What is the ratio of the Gender parity index (GPI) of Tertiary education in 1975 to that in 1979?
Keep it short and to the point. 1.28. What is the ratio of the Gender parity index (GPI) in Primary education in 1975 to that in 1980?
Give a very brief answer. 0.97. What is the ratio of the Gender parity index (GPI) in Secondary education in 1975 to that in 1980?
Your response must be concise. 0.82. What is the ratio of the Gender parity index (GPI) of Tertiary education in 1975 to that in 1980?
Give a very brief answer. 0.88. What is the ratio of the Gender parity index (GPI) in Primary education in 1975 to that in 1981?
Your answer should be compact. 0.91. What is the ratio of the Gender parity index (GPI) of Secondary education in 1975 to that in 1981?
Give a very brief answer. 0.87. What is the ratio of the Gender parity index (GPI) in Tertiary education in 1975 to that in 1981?
Ensure brevity in your answer.  0.9. What is the ratio of the Gender parity index (GPI) in Primary education in 1975 to that in 1982?
Make the answer very short. 0.96. What is the ratio of the Gender parity index (GPI) in Secondary education in 1975 to that in 1982?
Provide a succinct answer. 0.91. What is the ratio of the Gender parity index (GPI) in Tertiary education in 1975 to that in 1982?
Provide a short and direct response. 0.72. What is the ratio of the Gender parity index (GPI) in Primary education in 1975 to that in 1983?
Keep it short and to the point. 0.97. What is the ratio of the Gender parity index (GPI) in Secondary education in 1975 to that in 1983?
Give a very brief answer. 0.85. What is the ratio of the Gender parity index (GPI) in Tertiary education in 1975 to that in 1983?
Your answer should be very brief. 0.42. What is the ratio of the Gender parity index (GPI) of Secondary education in 1976 to that in 1977?
Make the answer very short. 0.94. What is the ratio of the Gender parity index (GPI) in Tertiary education in 1976 to that in 1977?
Your answer should be compact. 1.7. What is the ratio of the Gender parity index (GPI) of Primary education in 1976 to that in 1978?
Your answer should be compact. 0.99. What is the ratio of the Gender parity index (GPI) of Secondary education in 1976 to that in 1978?
Make the answer very short. 0.76. What is the ratio of the Gender parity index (GPI) of Tertiary education in 1976 to that in 1978?
Keep it short and to the point. 1.54. What is the ratio of the Gender parity index (GPI) of Primary education in 1976 to that in 1979?
Offer a very short reply. 0.99. What is the ratio of the Gender parity index (GPI) of Secondary education in 1976 to that in 1979?
Provide a succinct answer. 0.77. What is the ratio of the Gender parity index (GPI) in Tertiary education in 1976 to that in 1979?
Your answer should be compact. 1.79. What is the ratio of the Gender parity index (GPI) of Primary education in 1976 to that in 1980?
Offer a terse response. 0.99. What is the ratio of the Gender parity index (GPI) in Secondary education in 1976 to that in 1980?
Ensure brevity in your answer.  0.79. What is the ratio of the Gender parity index (GPI) in Tertiary education in 1976 to that in 1980?
Offer a very short reply. 1.23. What is the ratio of the Gender parity index (GPI) in Primary education in 1976 to that in 1981?
Provide a short and direct response. 0.93. What is the ratio of the Gender parity index (GPI) in Secondary education in 1976 to that in 1981?
Give a very brief answer. 0.83. What is the ratio of the Gender parity index (GPI) in Tertiary education in 1976 to that in 1981?
Offer a very short reply. 1.25. What is the ratio of the Gender parity index (GPI) of Primary education in 1976 to that in 1982?
Make the answer very short. 0.98. What is the ratio of the Gender parity index (GPI) in Secondary education in 1976 to that in 1982?
Your response must be concise. 0.87. What is the ratio of the Gender parity index (GPI) in Secondary education in 1976 to that in 1983?
Keep it short and to the point. 0.81. What is the ratio of the Gender parity index (GPI) of Tertiary education in 1976 to that in 1983?
Your answer should be very brief. 0.59. What is the ratio of the Gender parity index (GPI) of Primary education in 1977 to that in 1978?
Offer a very short reply. 1. What is the ratio of the Gender parity index (GPI) in Secondary education in 1977 to that in 1978?
Provide a short and direct response. 0.81. What is the ratio of the Gender parity index (GPI) in Tertiary education in 1977 to that in 1978?
Ensure brevity in your answer.  0.91. What is the ratio of the Gender parity index (GPI) in Primary education in 1977 to that in 1979?
Your answer should be compact. 1. What is the ratio of the Gender parity index (GPI) of Secondary education in 1977 to that in 1979?
Keep it short and to the point. 0.82. What is the ratio of the Gender parity index (GPI) of Tertiary education in 1977 to that in 1979?
Your answer should be compact. 1.05. What is the ratio of the Gender parity index (GPI) of Primary education in 1977 to that in 1980?
Offer a terse response. 0.99. What is the ratio of the Gender parity index (GPI) of Secondary education in 1977 to that in 1980?
Offer a very short reply. 0.84. What is the ratio of the Gender parity index (GPI) of Tertiary education in 1977 to that in 1980?
Offer a very short reply. 0.72. What is the ratio of the Gender parity index (GPI) in Primary education in 1977 to that in 1981?
Offer a very short reply. 0.93. What is the ratio of the Gender parity index (GPI) in Secondary education in 1977 to that in 1981?
Make the answer very short. 0.89. What is the ratio of the Gender parity index (GPI) in Tertiary education in 1977 to that in 1981?
Provide a short and direct response. 0.74. What is the ratio of the Gender parity index (GPI) in Primary education in 1977 to that in 1982?
Give a very brief answer. 0.98. What is the ratio of the Gender parity index (GPI) in Secondary education in 1977 to that in 1982?
Your response must be concise. 0.93. What is the ratio of the Gender parity index (GPI) in Tertiary education in 1977 to that in 1982?
Provide a succinct answer. 0.58. What is the ratio of the Gender parity index (GPI) in Secondary education in 1977 to that in 1983?
Give a very brief answer. 0.86. What is the ratio of the Gender parity index (GPI) in Tertiary education in 1977 to that in 1983?
Offer a terse response. 0.35. What is the ratio of the Gender parity index (GPI) in Tertiary education in 1978 to that in 1979?
Your answer should be very brief. 1.16. What is the ratio of the Gender parity index (GPI) of Primary education in 1978 to that in 1980?
Your answer should be compact. 0.99. What is the ratio of the Gender parity index (GPI) in Secondary education in 1978 to that in 1980?
Provide a short and direct response. 1.03. What is the ratio of the Gender parity index (GPI) in Tertiary education in 1978 to that in 1980?
Give a very brief answer. 0.8. What is the ratio of the Gender parity index (GPI) in Primary education in 1978 to that in 1981?
Keep it short and to the point. 0.93. What is the ratio of the Gender parity index (GPI) in Secondary education in 1978 to that in 1981?
Provide a short and direct response. 1.09. What is the ratio of the Gender parity index (GPI) in Tertiary education in 1978 to that in 1981?
Your response must be concise. 0.81. What is the ratio of the Gender parity index (GPI) in Primary education in 1978 to that in 1982?
Provide a succinct answer. 0.98. What is the ratio of the Gender parity index (GPI) of Secondary education in 1978 to that in 1982?
Your answer should be very brief. 1.14. What is the ratio of the Gender parity index (GPI) in Tertiary education in 1978 to that in 1982?
Your answer should be compact. 0.65. What is the ratio of the Gender parity index (GPI) in Secondary education in 1978 to that in 1983?
Give a very brief answer. 1.06. What is the ratio of the Gender parity index (GPI) in Tertiary education in 1978 to that in 1983?
Offer a terse response. 0.38. What is the ratio of the Gender parity index (GPI) in Primary education in 1979 to that in 1980?
Give a very brief answer. 0.99. What is the ratio of the Gender parity index (GPI) in Secondary education in 1979 to that in 1980?
Make the answer very short. 1.03. What is the ratio of the Gender parity index (GPI) of Tertiary education in 1979 to that in 1980?
Give a very brief answer. 0.69. What is the ratio of the Gender parity index (GPI) in Primary education in 1979 to that in 1981?
Provide a short and direct response. 0.93. What is the ratio of the Gender parity index (GPI) of Secondary education in 1979 to that in 1981?
Provide a succinct answer. 1.08. What is the ratio of the Gender parity index (GPI) of Tertiary education in 1979 to that in 1981?
Provide a short and direct response. 0.7. What is the ratio of the Gender parity index (GPI) of Primary education in 1979 to that in 1982?
Your answer should be compact. 0.99. What is the ratio of the Gender parity index (GPI) in Secondary education in 1979 to that in 1982?
Provide a succinct answer. 1.13. What is the ratio of the Gender parity index (GPI) in Tertiary education in 1979 to that in 1982?
Give a very brief answer. 0.56. What is the ratio of the Gender parity index (GPI) of Secondary education in 1979 to that in 1983?
Provide a succinct answer. 1.06. What is the ratio of the Gender parity index (GPI) in Tertiary education in 1979 to that in 1983?
Your answer should be compact. 0.33. What is the ratio of the Gender parity index (GPI) in Primary education in 1980 to that in 1981?
Provide a short and direct response. 0.94. What is the ratio of the Gender parity index (GPI) in Secondary education in 1980 to that in 1981?
Your answer should be compact. 1.06. What is the ratio of the Gender parity index (GPI) in Tertiary education in 1980 to that in 1981?
Keep it short and to the point. 1.02. What is the ratio of the Gender parity index (GPI) of Secondary education in 1980 to that in 1982?
Your answer should be very brief. 1.11. What is the ratio of the Gender parity index (GPI) in Tertiary education in 1980 to that in 1982?
Provide a succinct answer. 0.81. What is the ratio of the Gender parity index (GPI) in Secondary education in 1980 to that in 1983?
Your answer should be very brief. 1.03. What is the ratio of the Gender parity index (GPI) in Tertiary education in 1980 to that in 1983?
Ensure brevity in your answer.  0.48. What is the ratio of the Gender parity index (GPI) of Primary education in 1981 to that in 1982?
Offer a terse response. 1.06. What is the ratio of the Gender parity index (GPI) in Secondary education in 1981 to that in 1982?
Your response must be concise. 1.05. What is the ratio of the Gender parity index (GPI) in Tertiary education in 1981 to that in 1982?
Offer a terse response. 0.79. What is the ratio of the Gender parity index (GPI) in Primary education in 1981 to that in 1983?
Ensure brevity in your answer.  1.07. What is the ratio of the Gender parity index (GPI) in Secondary education in 1981 to that in 1983?
Offer a terse response. 0.98. What is the ratio of the Gender parity index (GPI) in Tertiary education in 1981 to that in 1983?
Offer a terse response. 0.47. What is the ratio of the Gender parity index (GPI) in Primary education in 1982 to that in 1983?
Ensure brevity in your answer.  1.01. What is the ratio of the Gender parity index (GPI) of Secondary education in 1982 to that in 1983?
Offer a very short reply. 0.93. What is the ratio of the Gender parity index (GPI) of Tertiary education in 1982 to that in 1983?
Your response must be concise. 0.59. What is the difference between the highest and the second highest Gender parity index (GPI) in Primary education?
Ensure brevity in your answer.  0.06. What is the difference between the highest and the second highest Gender parity index (GPI) of Secondary education?
Make the answer very short. 0. What is the difference between the highest and the second highest Gender parity index (GPI) in Tertiary education?
Your answer should be compact. 1.02. What is the difference between the highest and the lowest Gender parity index (GPI) in Primary education?
Your answer should be very brief. 0.1. What is the difference between the highest and the lowest Gender parity index (GPI) in Secondary education?
Offer a very short reply. 0.39. What is the difference between the highest and the lowest Gender parity index (GPI) of Tertiary education?
Provide a succinct answer. 1.68. 